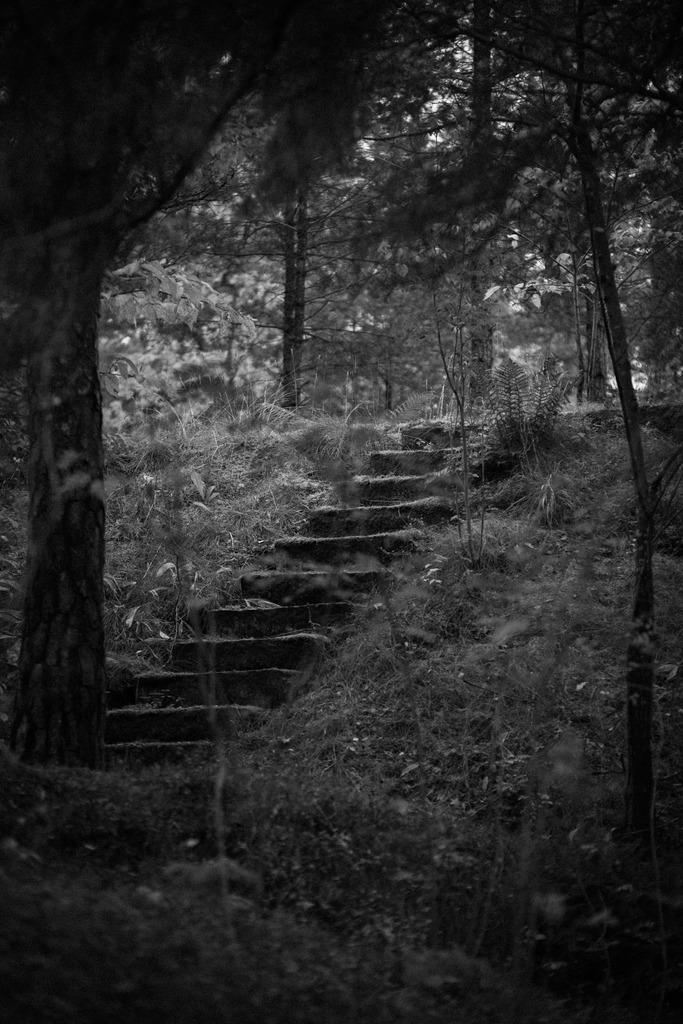Can you describe this image briefly? This is a black and white image. In the middle of the image there are few stairs. On the both sides, I can see the grass and plants. On the left side there is a tree trunk. In the background there are many trees. At the bottom there are many plants. 